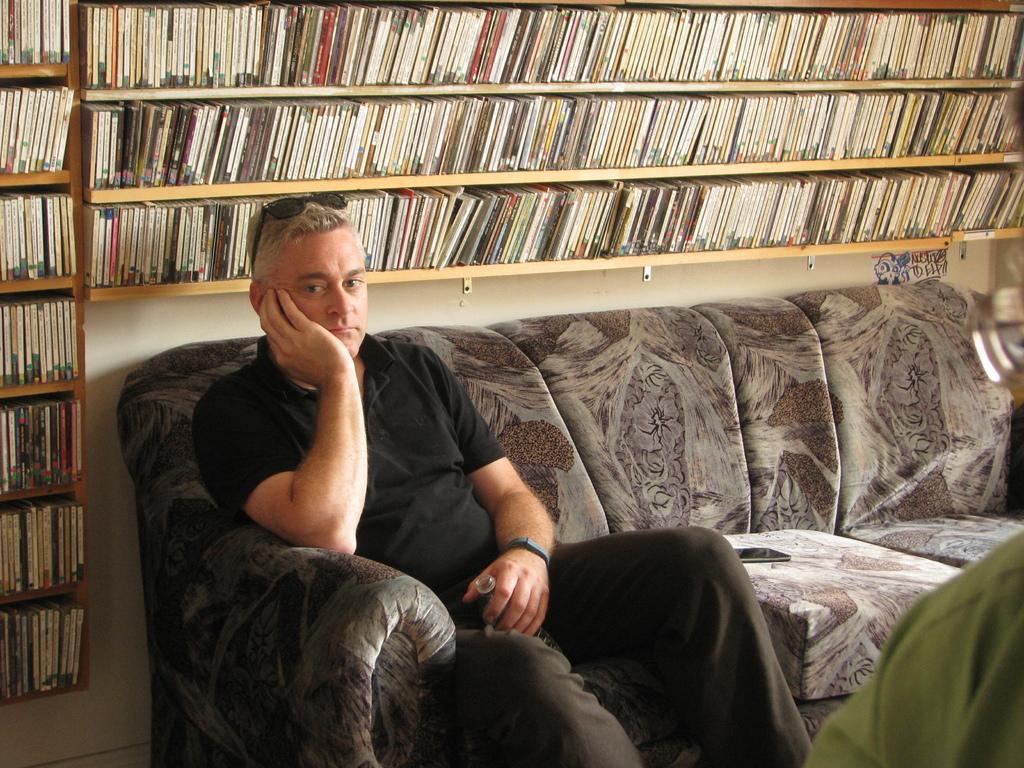How would you summarize this image in a sentence or two? In this image there is a sofa, a man is sitting on sofa holding a bottle in his hand, in the background there is a shelf, in that shelf there are books. 